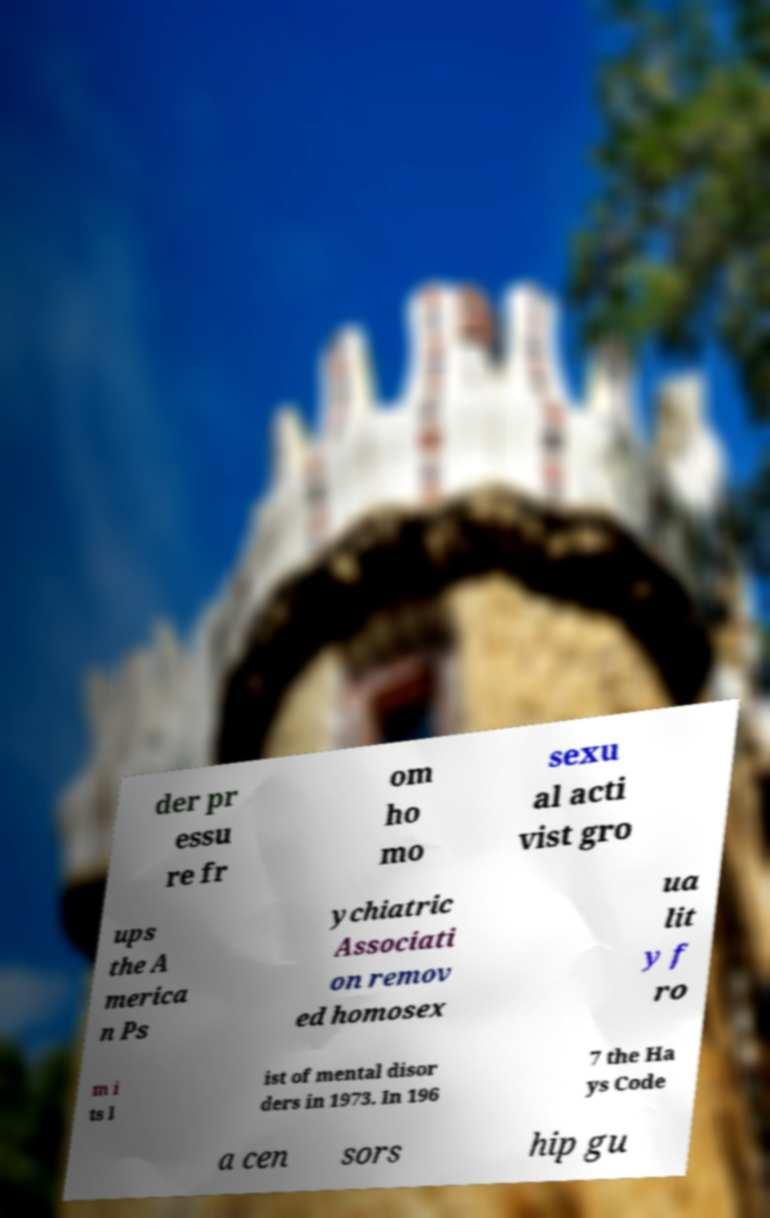Can you accurately transcribe the text from the provided image for me? der pr essu re fr om ho mo sexu al acti vist gro ups the A merica n Ps ychiatric Associati on remov ed homosex ua lit y f ro m i ts l ist of mental disor ders in 1973. In 196 7 the Ha ys Code a cen sors hip gu 